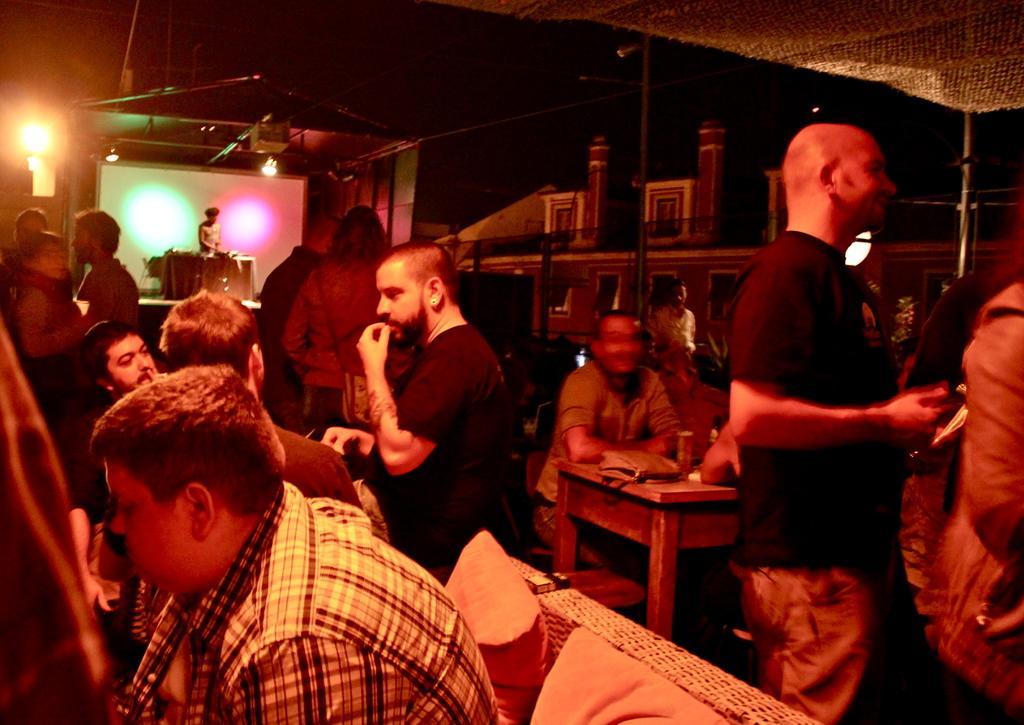How would you summarize this image in a sentence or two? In this picture we can see a group of people where some are sitting and some are standing, pillows, table and in the background we can see a person standing on stage, lights. 